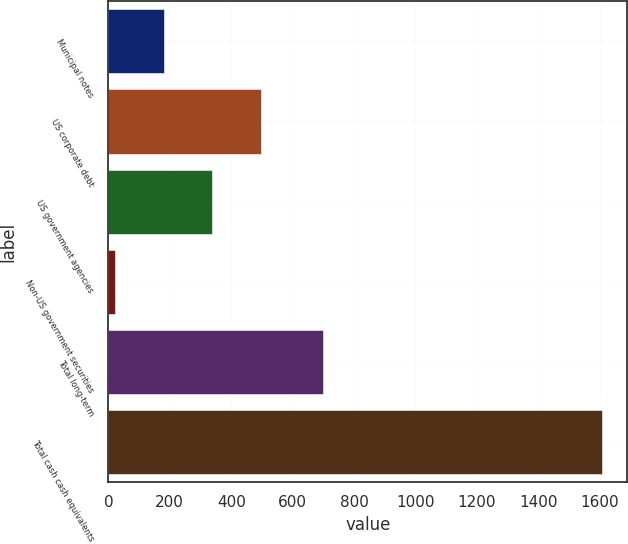Convert chart to OTSL. <chart><loc_0><loc_0><loc_500><loc_500><bar_chart><fcel>Municipal notes<fcel>US corporate debt<fcel>US government agencies<fcel>Non-US government securities<fcel>Total long-term<fcel>Total cash cash equivalents<nl><fcel>179.97<fcel>497.51<fcel>338.74<fcel>21.2<fcel>698.5<fcel>1608.9<nl></chart> 